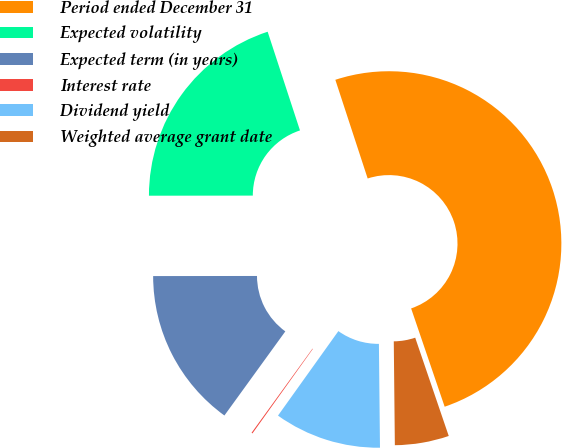<chart> <loc_0><loc_0><loc_500><loc_500><pie_chart><fcel>Period ended December 31<fcel>Expected volatility<fcel>Expected term (in years)<fcel>Interest rate<fcel>Dividend yield<fcel>Weighted average grant date<nl><fcel>49.81%<fcel>19.98%<fcel>15.01%<fcel>0.1%<fcel>10.04%<fcel>5.07%<nl></chart> 